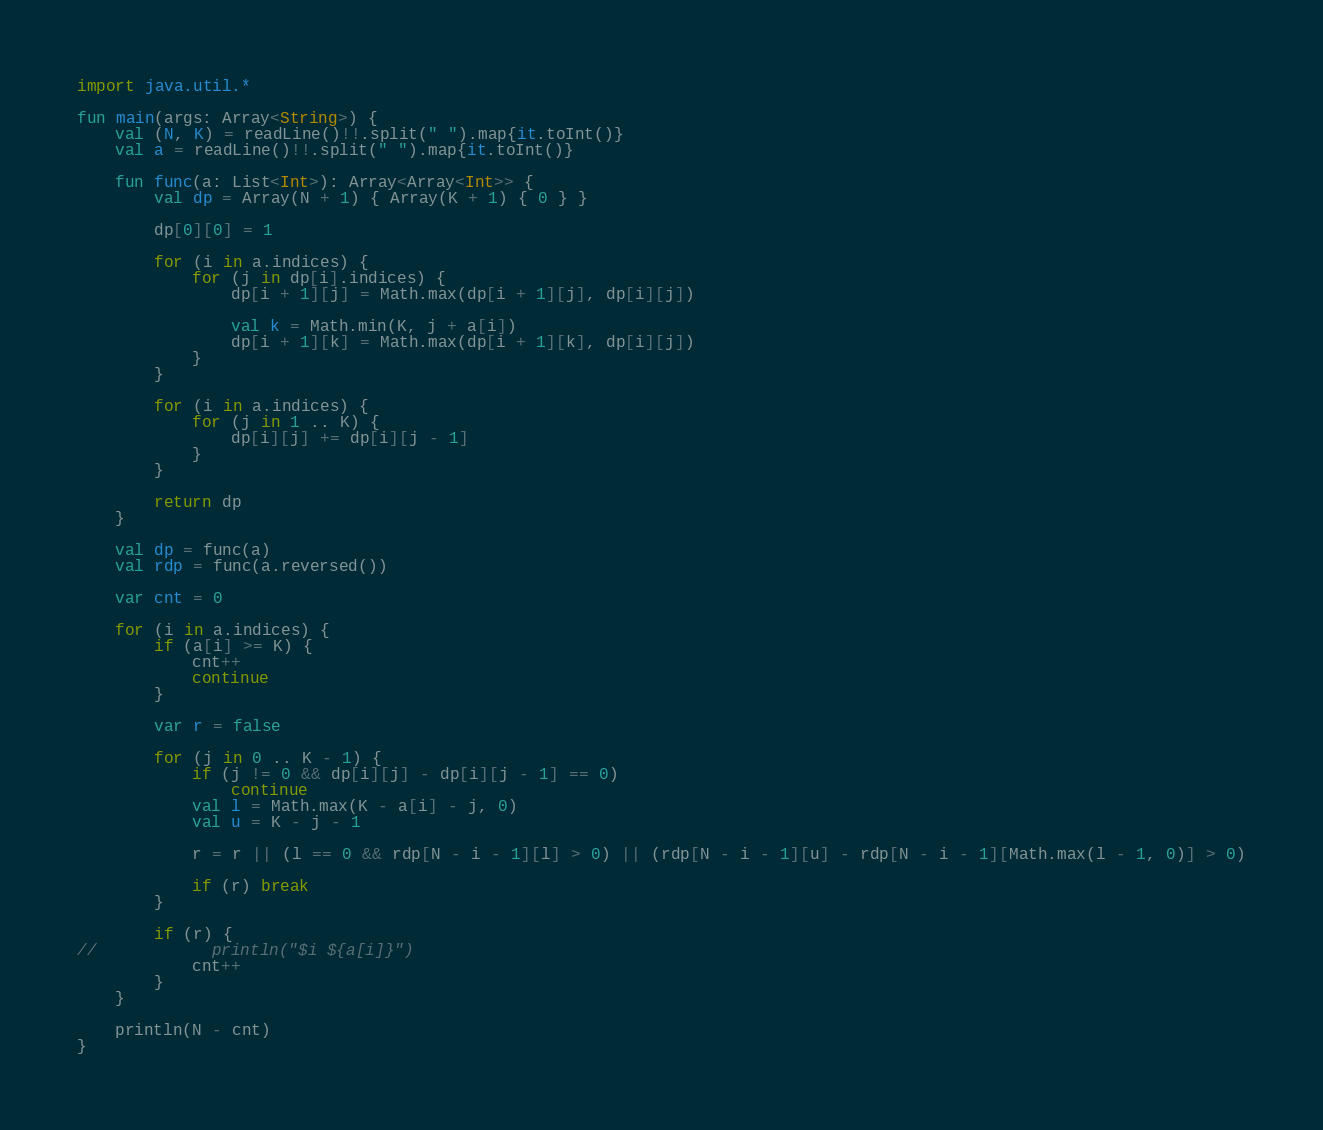Convert code to text. <code><loc_0><loc_0><loc_500><loc_500><_Kotlin_>import java.util.*

fun main(args: Array<String>) {
    val (N, K) = readLine()!!.split(" ").map{it.toInt()}
    val a = readLine()!!.split(" ").map{it.toInt()}

    fun func(a: List<Int>): Array<Array<Int>> {
        val dp = Array(N + 1) { Array(K + 1) { 0 } }

        dp[0][0] = 1

        for (i in a.indices) {
            for (j in dp[i].indices) {
                dp[i + 1][j] = Math.max(dp[i + 1][j], dp[i][j])

                val k = Math.min(K, j + a[i])
                dp[i + 1][k] = Math.max(dp[i + 1][k], dp[i][j])
            }
        }

        for (i in a.indices) {
            for (j in 1 .. K) {
                dp[i][j] += dp[i][j - 1]
            }
        }

        return dp
    }

    val dp = func(a)
    val rdp = func(a.reversed())

    var cnt = 0

    for (i in a.indices) {
        if (a[i] >= K) {
            cnt++
            continue
        }

        var r = false

        for (j in 0 .. K - 1) {
            if (j != 0 && dp[i][j] - dp[i][j - 1] == 0)
                continue
            val l = Math.max(K - a[i] - j, 0)
            val u = K - j - 1

            r = r || (l == 0 && rdp[N - i - 1][l] > 0) || (rdp[N - i - 1][u] - rdp[N - i - 1][Math.max(l - 1, 0)] > 0)
            
            if (r) break
        }

        if (r) {
//            println("$i ${a[i]}")
            cnt++
        }
    }

    println(N - cnt)
}
</code> 